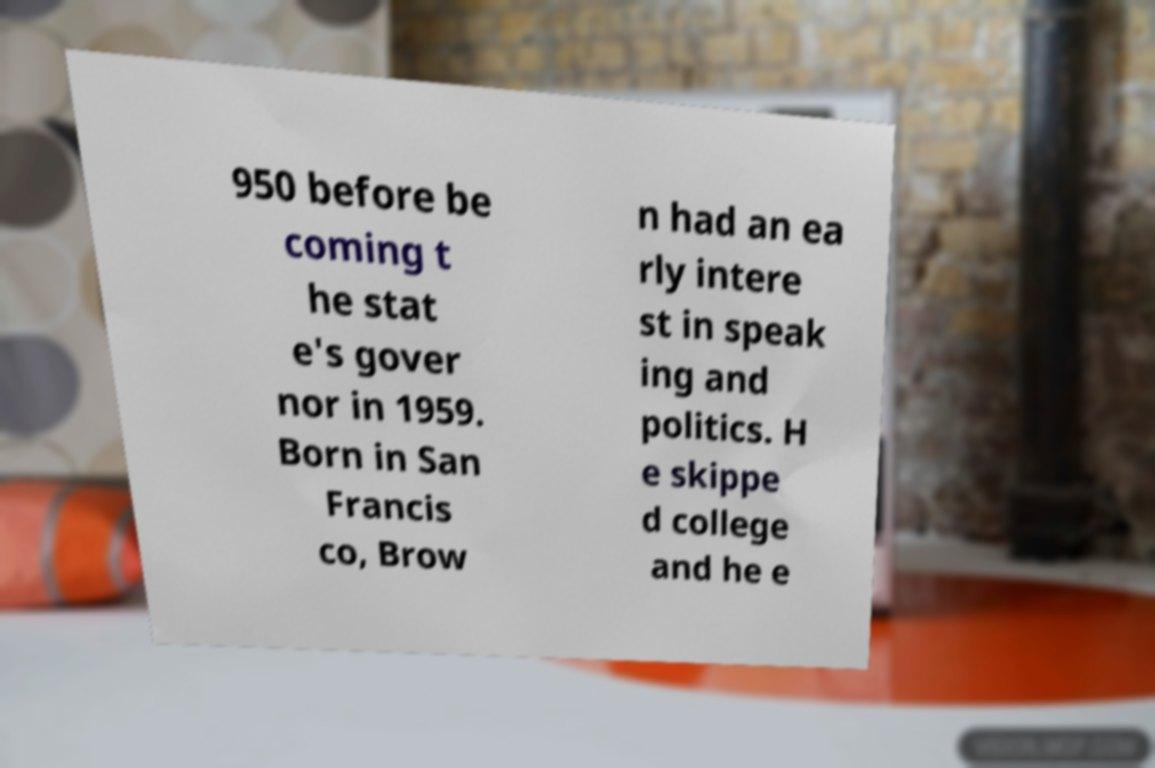For documentation purposes, I need the text within this image transcribed. Could you provide that? 950 before be coming t he stat e's gover nor in 1959. Born in San Francis co, Brow n had an ea rly intere st in speak ing and politics. H e skippe d college and he e 